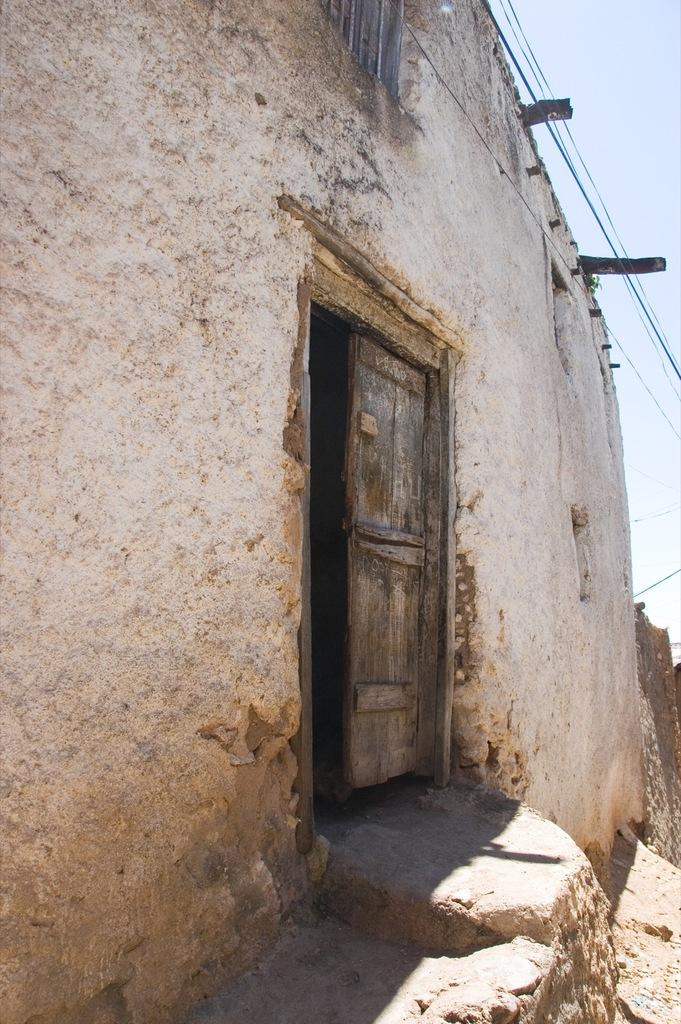What type of structure is in the picture? There is a house in the picture. Where is the main entrance to the house located? There is a door in the middle of the house. What can be seen in the background of the picture? The sky is visible in the picture. What is present at the top of the picture? There are wires at the top of the picture. What type of rice is being cooked in the house in the picture? There is no indication of any rice or cooking activity in the picture; it only shows a house with a door and wires at the top. 